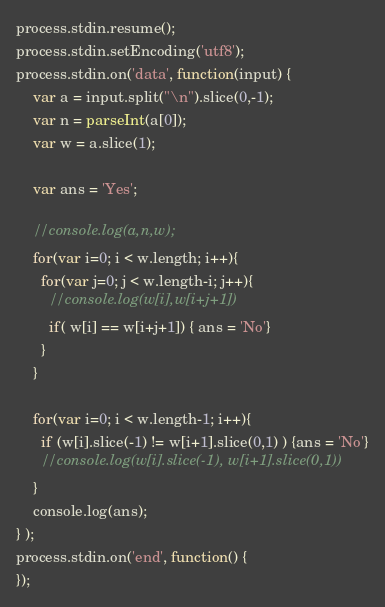Convert code to text. <code><loc_0><loc_0><loc_500><loc_500><_JavaScript_>process.stdin.resume();
process.stdin.setEncoding('utf8');
process.stdin.on('data', function(input) {
    var a = input.split("\n").slice(0,-1);
    var n = parseInt(a[0]);
    var w = a.slice(1);
    
    var ans = 'Yes';

    //console.log(a,n,w);
    for(var i=0; i < w.length; i++){
      for(var j=0; j < w.length-i; j++){
        //console.log(w[i],w[i+j+1])
        if( w[i] == w[i+j+1]) { ans = 'No'}
      }
    }

    for(var i=0; i < w.length-1; i++){
      if (w[i].slice(-1) != w[i+1].slice(0,1) ) {ans = 'No'}
      //console.log(w[i].slice(-1), w[i+1].slice(0,1))
    }
    console.log(ans);
} );
process.stdin.on('end', function() {
});</code> 